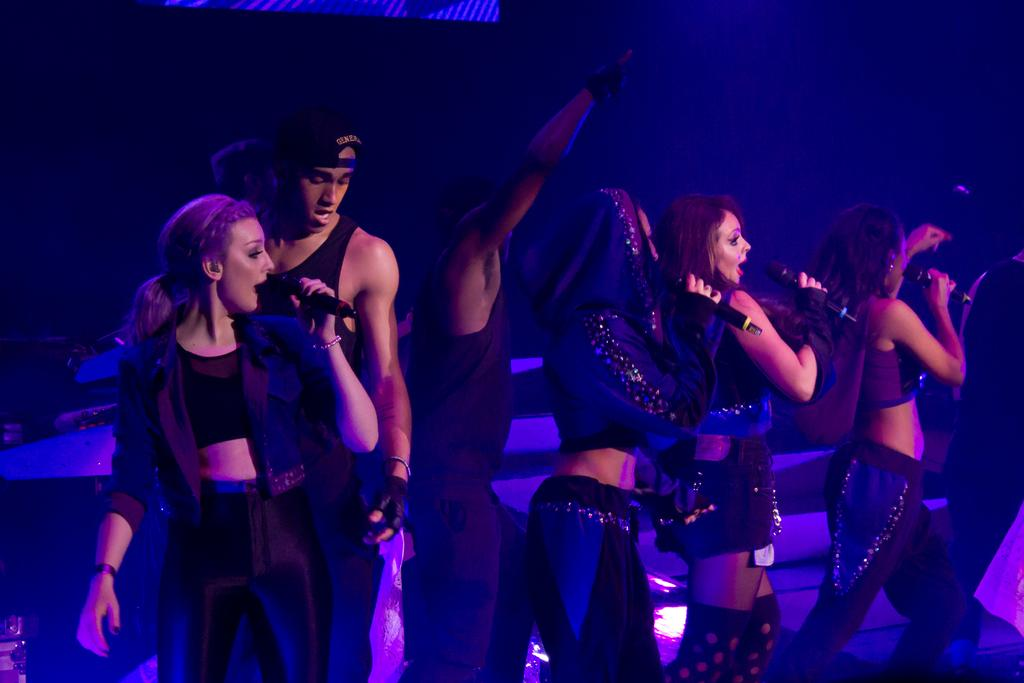What is happening on the stage in the image? There are people standing on the stage, and they are singing. What are the people holding while they are singing? The people are holding microphones. Can you see any cherries on the stage in the image? There are no cherries visible on the stage in the image. Is there a zipper on the microphones being held by the people on the stage? The microphones being held by the people on the stage do not have zippers; they are electronic devices for amplifying sound. 